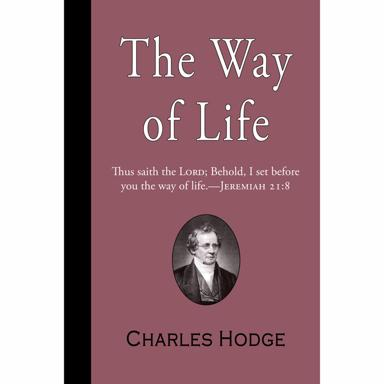What might be the significance of the Jeremiah 21:8 verse on the cover? The verse 'Behold, I set before you the way of life' (Jeremiah 21:8), prominently featured on the cover, encapsulates a core theme of biblical decision-making and moral path choices, resonant with Hodge's theological emphasis. This verse serves as a profound invitation to readers to reflect on the biblical guidance for righteous living and ethical dilemmas, aligning well with Hodge's focus on scriptural authority in everyday life. 